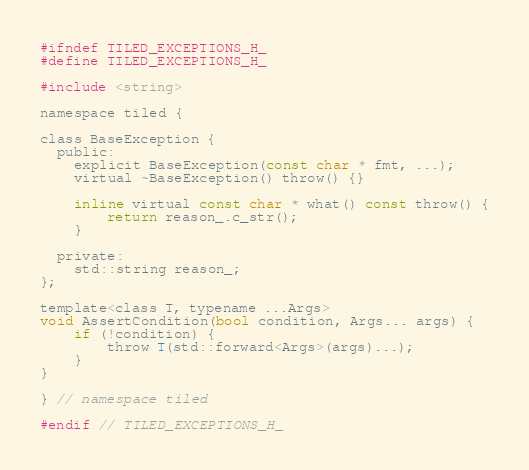Convert code to text. <code><loc_0><loc_0><loc_500><loc_500><_C_>#ifndef TILED_EXCEPTIONS_H_
#define TILED_EXCEPTIONS_H_

#include <string>

namespace tiled {

class BaseException {
  public:
    explicit BaseException(const char * fmt, ...); 
    virtual ~BaseException() throw() {}

    inline virtual const char * what() const throw() {
        return reason_.c_str();
    }

  private:
    std::string reason_;
};

template<class T, typename ...Args>
void AssertCondition(bool condition, Args... args) {
    if (!condition) {
        throw T(std::forward<Args>(args)...);
    }
}

} // namespace tiled

#endif // TILED_EXCEPTIONS_H_</code> 